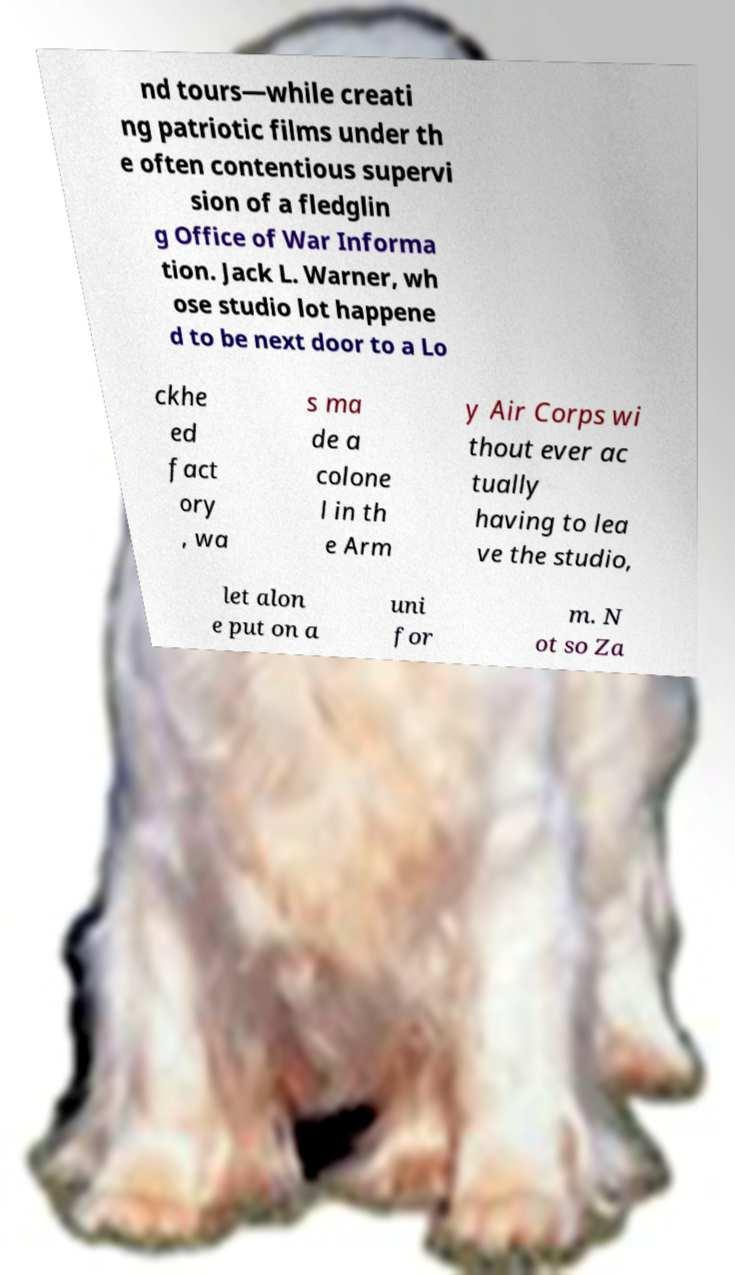Please read and relay the text visible in this image. What does it say? nd tours—while creati ng patriotic films under th e often contentious supervi sion of a fledglin g Office of War Informa tion. Jack L. Warner, wh ose studio lot happene d to be next door to a Lo ckhe ed fact ory , wa s ma de a colone l in th e Arm y Air Corps wi thout ever ac tually having to lea ve the studio, let alon e put on a uni for m. N ot so Za 